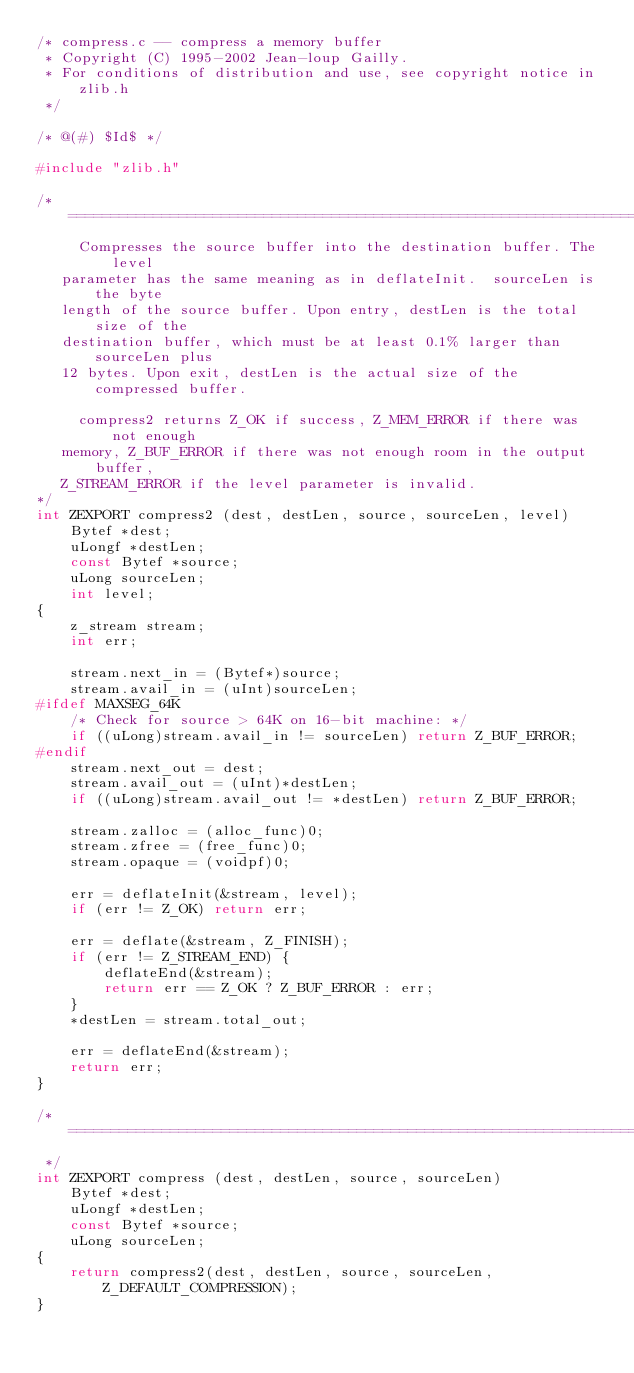<code> <loc_0><loc_0><loc_500><loc_500><_C_>/* compress.c -- compress a memory buffer
 * Copyright (C) 1995-2002 Jean-loup Gailly.
 * For conditions of distribution and use, see copyright notice in zlib.h 
 */

/* @(#) $Id$ */

#include "zlib.h"

/* ===========================================================================
     Compresses the source buffer into the destination buffer. The level
   parameter has the same meaning as in deflateInit.  sourceLen is the byte
   length of the source buffer. Upon entry, destLen is the total size of the
   destination buffer, which must be at least 0.1% larger than sourceLen plus
   12 bytes. Upon exit, destLen is the actual size of the compressed buffer.

     compress2 returns Z_OK if success, Z_MEM_ERROR if there was not enough
   memory, Z_BUF_ERROR if there was not enough room in the output buffer,
   Z_STREAM_ERROR if the level parameter is invalid.
*/
int ZEXPORT compress2 (dest, destLen, source, sourceLen, level)
    Bytef *dest;
    uLongf *destLen;
    const Bytef *source;
    uLong sourceLen;
    int level;
{
    z_stream stream;
    int err;

    stream.next_in = (Bytef*)source;
    stream.avail_in = (uInt)sourceLen;
#ifdef MAXSEG_64K
    /* Check for source > 64K on 16-bit machine: */
    if ((uLong)stream.avail_in != sourceLen) return Z_BUF_ERROR;
#endif
    stream.next_out = dest;
    stream.avail_out = (uInt)*destLen;
    if ((uLong)stream.avail_out != *destLen) return Z_BUF_ERROR;

    stream.zalloc = (alloc_func)0;
    stream.zfree = (free_func)0;
    stream.opaque = (voidpf)0;

    err = deflateInit(&stream, level);
    if (err != Z_OK) return err;

    err = deflate(&stream, Z_FINISH);
    if (err != Z_STREAM_END) {
        deflateEnd(&stream);
        return err == Z_OK ? Z_BUF_ERROR : err;
    }
    *destLen = stream.total_out;

    err = deflateEnd(&stream);
    return err;
}

/* ===========================================================================
 */
int ZEXPORT compress (dest, destLen, source, sourceLen)
    Bytef *dest;
    uLongf *destLen;
    const Bytef *source;
    uLong sourceLen;
{
    return compress2(dest, destLen, source, sourceLen, Z_DEFAULT_COMPRESSION);
}
</code> 